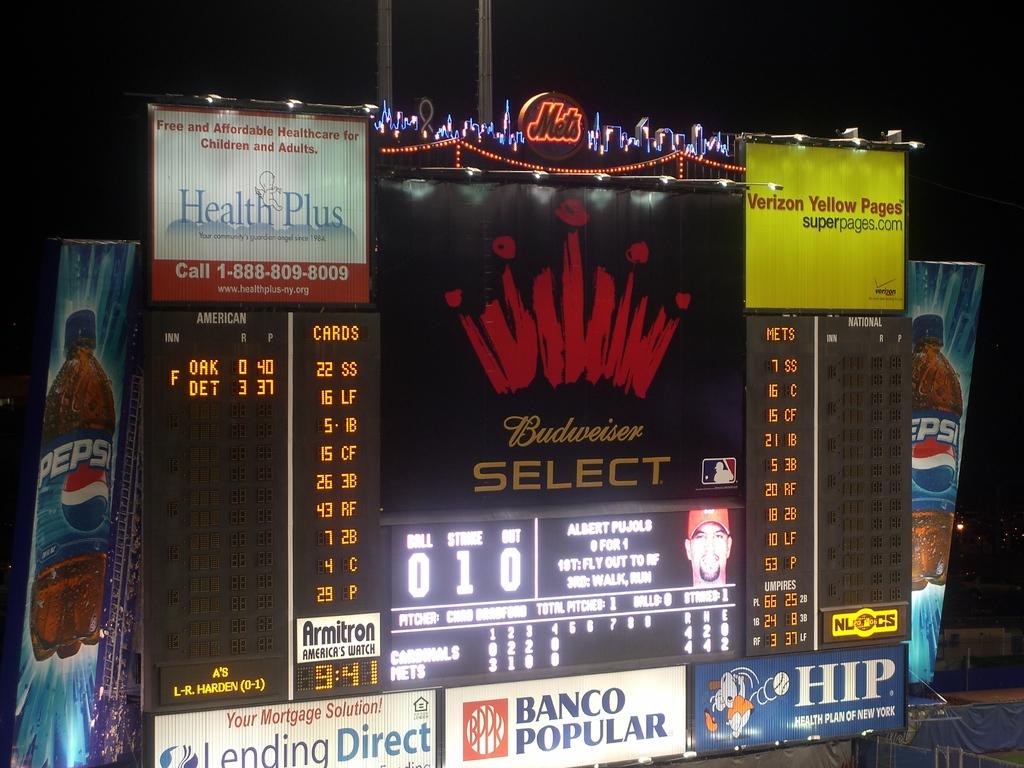Who is the beer sponsor for this game?
Keep it short and to the point. Budweiser. What soda is sponsoring this game?
Provide a succinct answer. Pepsi. 